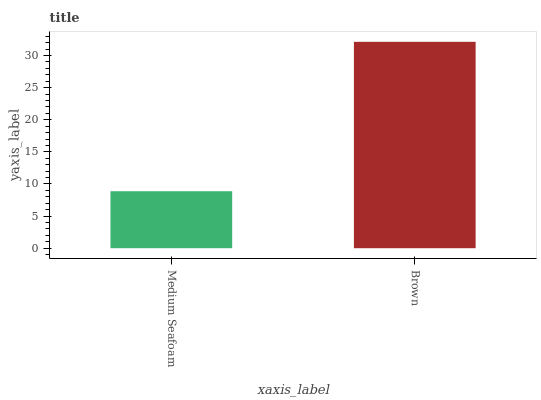Is Medium Seafoam the minimum?
Answer yes or no. Yes. Is Brown the maximum?
Answer yes or no. Yes. Is Brown the minimum?
Answer yes or no. No. Is Brown greater than Medium Seafoam?
Answer yes or no. Yes. Is Medium Seafoam less than Brown?
Answer yes or no. Yes. Is Medium Seafoam greater than Brown?
Answer yes or no. No. Is Brown less than Medium Seafoam?
Answer yes or no. No. Is Brown the high median?
Answer yes or no. Yes. Is Medium Seafoam the low median?
Answer yes or no. Yes. Is Medium Seafoam the high median?
Answer yes or no. No. Is Brown the low median?
Answer yes or no. No. 